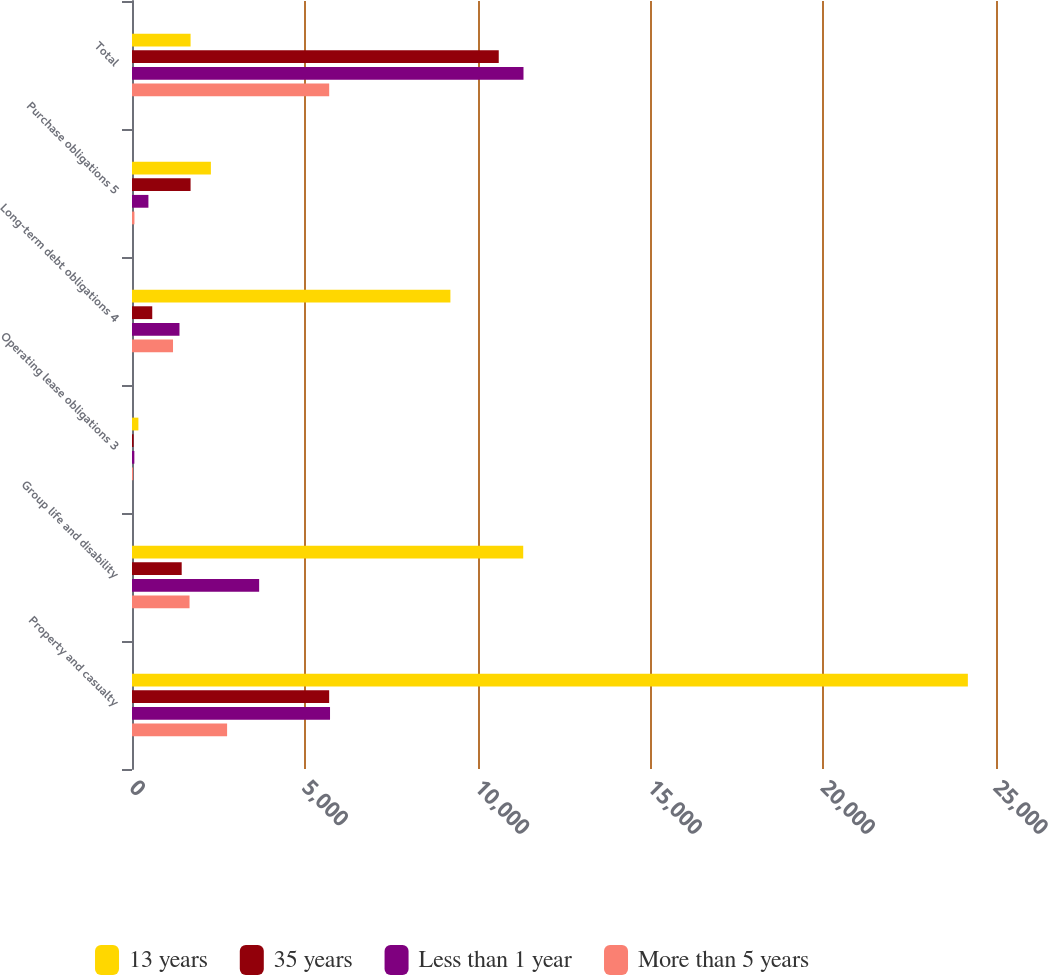<chart> <loc_0><loc_0><loc_500><loc_500><stacked_bar_chart><ecel><fcel>Property and casualty<fcel>Group life and disability<fcel>Operating lease obligations 3<fcel>Long-term debt obligations 4<fcel>Purchase obligations 5<fcel>Total<nl><fcel>13 years<fcel>24186<fcel>11320<fcel>185<fcel>9213<fcel>2283<fcel>1695<nl><fcel>35 years<fcel>5705<fcel>1438<fcel>45<fcel>586<fcel>1695<fcel>10612<nl><fcel>Less than 1 year<fcel>5730<fcel>3679<fcel>68<fcel>1374<fcel>475<fcel>11328<nl><fcel>More than 5 years<fcel>2752<fcel>1665<fcel>31<fcel>1187<fcel>71<fcel>5706<nl></chart> 